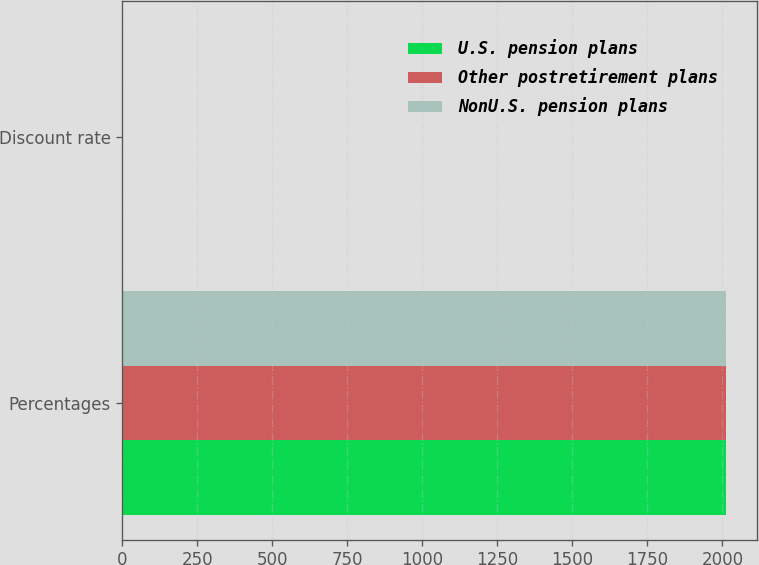Convert chart to OTSL. <chart><loc_0><loc_0><loc_500><loc_500><stacked_bar_chart><ecel><fcel>Percentages<fcel>Discount rate<nl><fcel>U.S. pension plans<fcel>2013<fcel>3.67<nl><fcel>Other postretirement plans<fcel>2013<fcel>3.85<nl><fcel>NonU.S. pension plans<fcel>2013<fcel>3.4<nl></chart> 